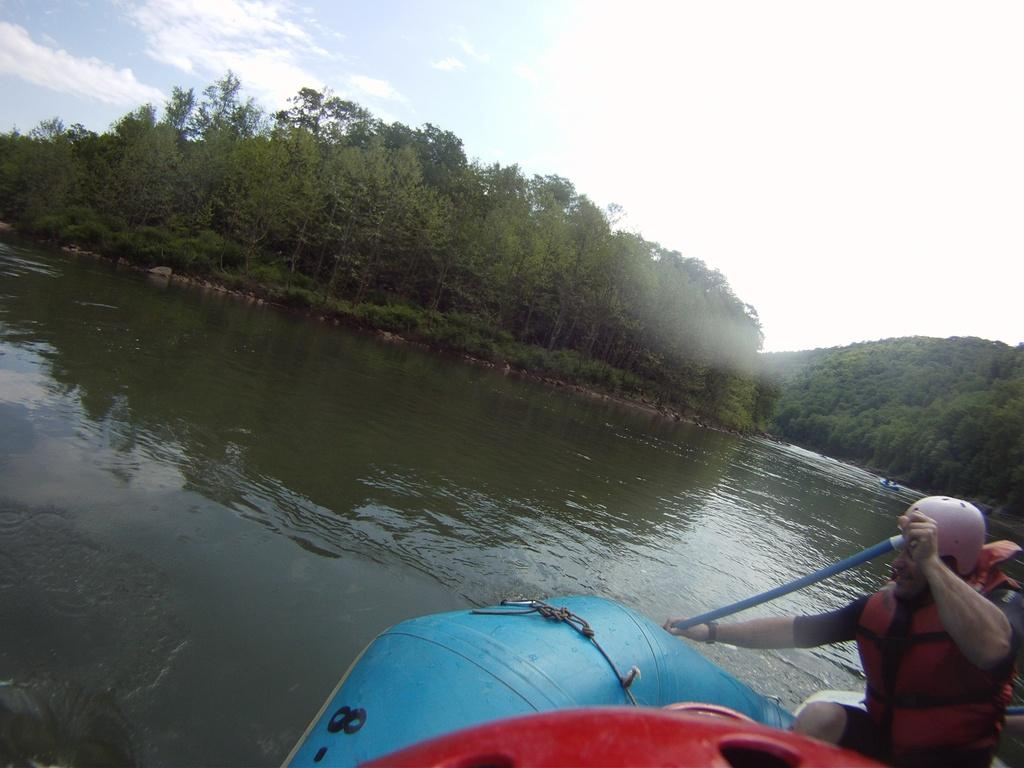What is the main subject of the image? There is a person in a boat on the water. Where is the boat located in the image? The boat is on the right side of the image. What can be seen in the background of the image? There are trees, plants, a mountain, and clouds in the sky in the background of the image. What type of needle is the person in the boat using to sew a basketball in the image? There is no needle or basketball present in the image; it features a person in a boat on the water with a background of trees, plants, a mountain, and clouds in the sky. 